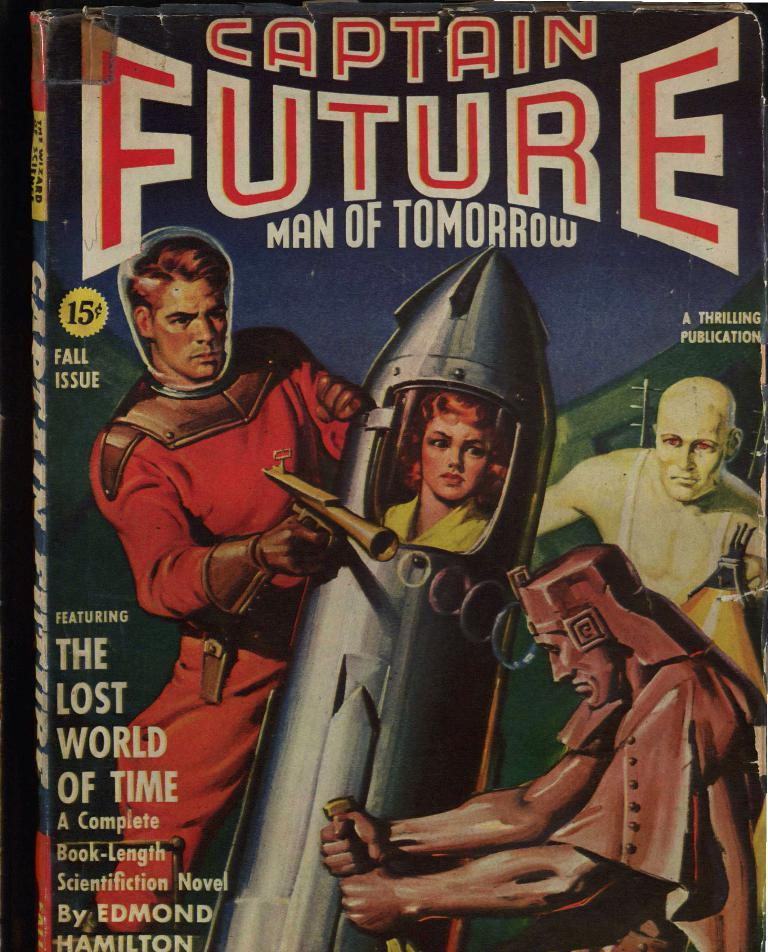<image>
Give a short and clear explanation of the subsequent image. An old Captain Future book shows him shooting a ray gun. 